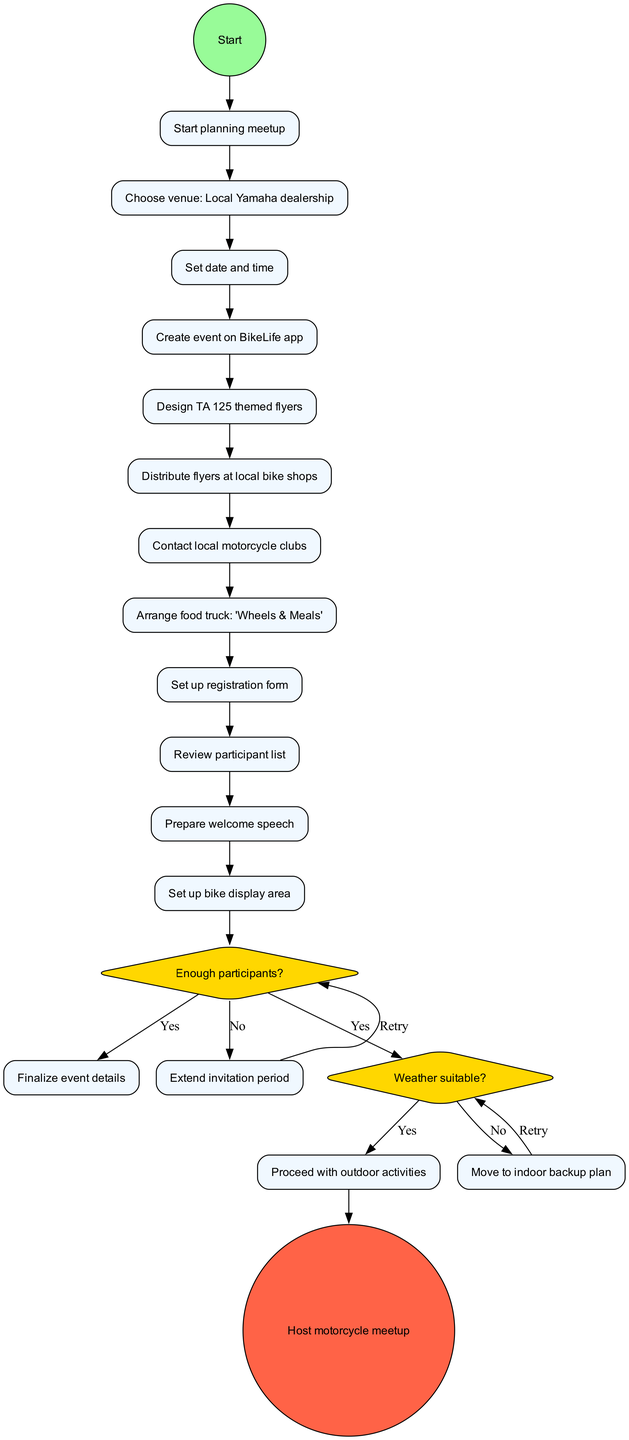What is the first activity listed in the diagram? The first activity listed after the initial node is "Choose venue: Local Yamaha dealership." It is the first element following the start planning meetup node, which represents the initiation of the event planning process.
Answer: Choose venue: Local Yamaha dealership How many activities are outlined in the diagram? There are eleven activities listed in the diagram, ranging from choosing a venue to setting up a bike display area, which are all part of organizing the meetup.
Answer: 11 What is the decision question related to participant count? The decision related to participant count is "Enough participants?" This question is directly associated with checking the readiness of the event based on the number of people interested in attending.
Answer: Enough participants? What happens if there are not enough participants? If there are not enough participants, the flow indicates to "Extend invitation period," meaning that more time will be given to invite additional attendees before finalizing event details.
Answer: Extend invitation period What is the last activity before the final node? The last activity before reaching the final node is "Prepare welcome speech." This task is critical, as it prepares the organizer to greet and engage with participants at the event.
Answer: Prepare welcome speech Which activity is connected to the decision about the weather? The activity connected to the weather decision is "Review participant list." This implies that checking the participant list occurs before considerations of whether to continue with planned outdoor activities based on weather conditions.
Answer: Review participant list If the weather is not suitable, what course of action is taken? If the weather is not suitable, the decision directs to "Move to indoor backup plan." This describes the contingency for unfavorable weather, ensuring the event can still proceed indoors.
Answer: Move to indoor backup plan How many decision nodes are present in the diagram? There are two decision nodes present in the diagram, which pertain to participant count and weather suitability. These nodes determine critical pathways based on specific criteria.
Answer: 2 What is the final node called in the activity diagram? The final node in the diagram is called "Host motorcycle meetup." This marks the conclusion of the planning process and signifies the successful execution of the event.
Answer: Host motorcycle meetup 